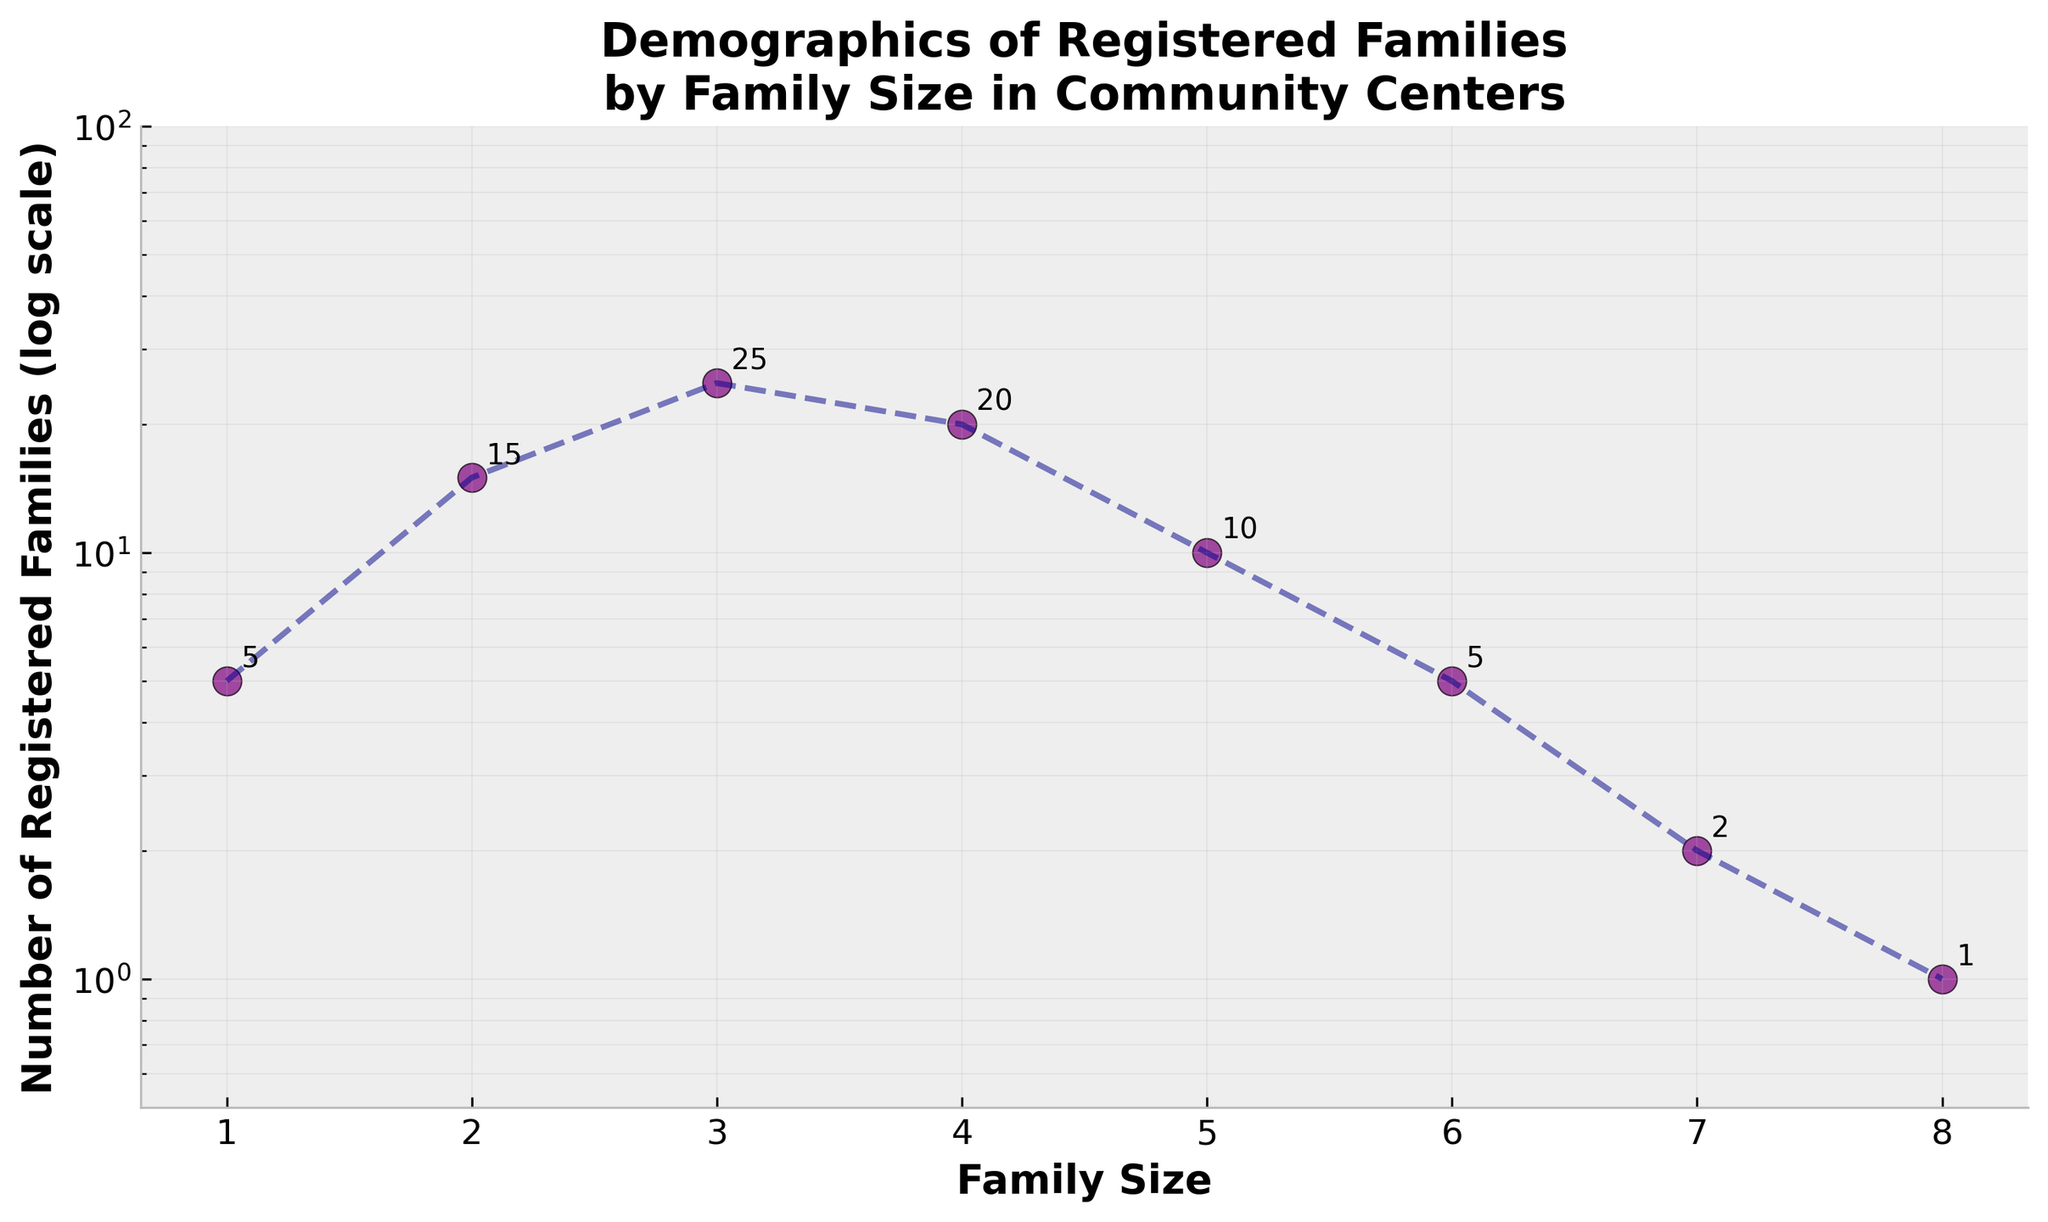What is the title of the figure? The title of the figure, typically located at the top, gives an overview of what the plot represents. Here it reads: "Demographics of Registered Families by Family Size in Community Centers".
Answer: Demographics of Registered Families by Family Size in Community Centers What is the family size with the highest number of registered families? The highest number of registered families is indicated by the tallest marker on the y-axis. According to the figure, the family size of 3 has the highest number, which is 25.
Answer: 3 What is the range of the number of registered families on the y-axis? The y-axis has a logarithmic scale with labeled ticks between 1 and 100. The minimum tick starts just above 0.5, and the maximum tick is at 100.
Answer: 0.5 to 100 How many families are registered with a family size of 7? Look for the marker corresponding to the family size of 7 on the x-axis. The number next to the marker indicates that there are 2 registered families.
Answer: 2 What is the general trend as family size increases? Following the plotted line and markers, the number of registered families generally decreases as family size increases.
Answer: Decreasing What is the total number of registered families with a family size greater than 4? Sum the number of registered families for family sizes 5, 6, 7, and 8. These are 10, 5, 2, and 1, respectively. Summing these values: 10 + 5 + 2 + 1 = 18.
Answer: 18 What is the difference in the number of registered families between the smallest and largest family sizes? The smallest family size is 1 with 5 registered families. The largest family size is 8 with 1 registered family. The difference is 5 - 1 = 4.
Answer: 4 Which family size has the lowest number of registered families? The lowest point on the y-axis corresponds to the family size of 8, which has 1 registered family.
Answer: 8 How many family sizes have more than 10 registered families? Count the markers above 10 on the y-axis. These correspond to family sizes 2, 3, and 4, each with more than 10 registered families.
Answer: 3 How does the number of registered families change between family sizes 2 and 4? The number of registered families for family size 2 is 15, for size 3 is 25, and for size 4 is 20. Between sizes 2 and 3, it increases by 10 (25-15). Between sizes 3 and 4, it decreases by 5 (25-20).
Answer: Increases then decreases 